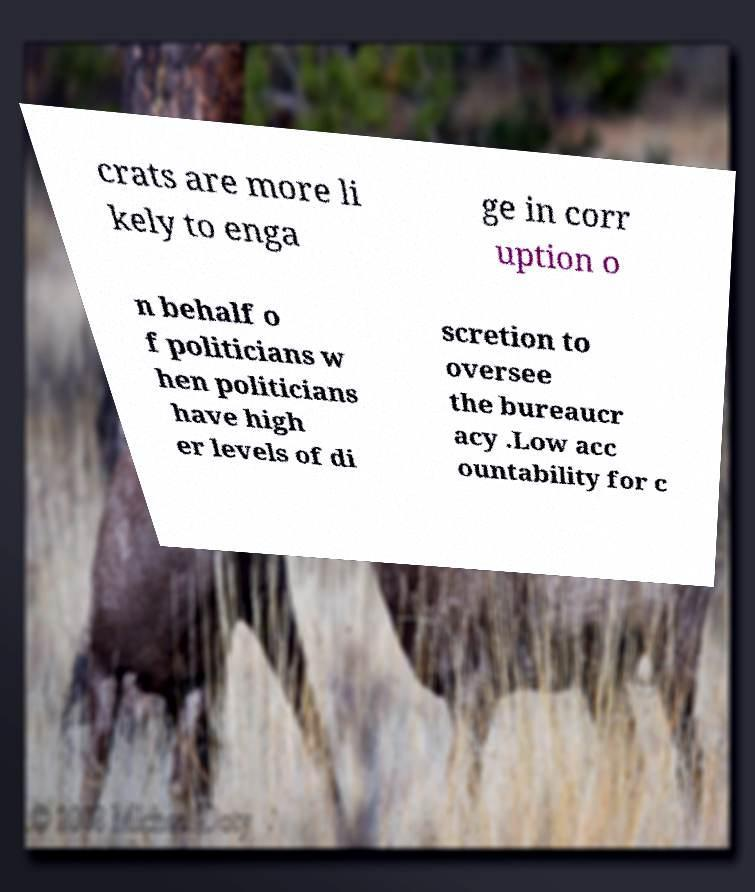For documentation purposes, I need the text within this image transcribed. Could you provide that? crats are more li kely to enga ge in corr uption o n behalf o f politicians w hen politicians have high er levels of di scretion to oversee the bureaucr acy .Low acc ountability for c 